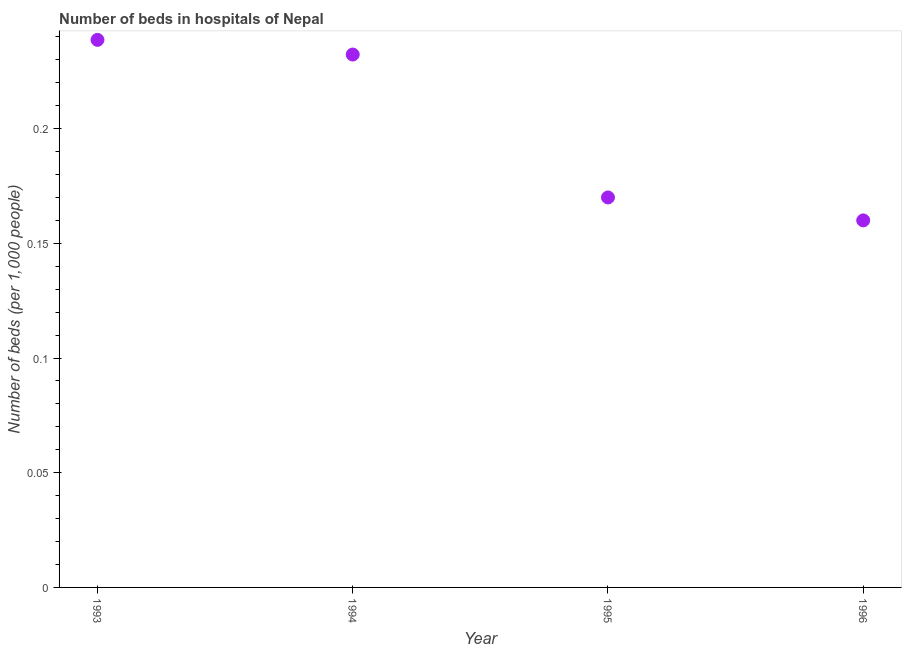What is the number of hospital beds in 1996?
Give a very brief answer. 0.16. Across all years, what is the maximum number of hospital beds?
Offer a terse response. 0.24. Across all years, what is the minimum number of hospital beds?
Your answer should be very brief. 0.16. In which year was the number of hospital beds maximum?
Provide a succinct answer. 1993. What is the sum of the number of hospital beds?
Your answer should be very brief. 0.8. What is the difference between the number of hospital beds in 1993 and 1996?
Make the answer very short. 0.08. What is the average number of hospital beds per year?
Your response must be concise. 0.2. What is the median number of hospital beds?
Keep it short and to the point. 0.2. What is the ratio of the number of hospital beds in 1993 to that in 1996?
Give a very brief answer. 1.49. What is the difference between the highest and the second highest number of hospital beds?
Keep it short and to the point. 0.01. What is the difference between the highest and the lowest number of hospital beds?
Offer a terse response. 0.08. In how many years, is the number of hospital beds greater than the average number of hospital beds taken over all years?
Your response must be concise. 2. How many dotlines are there?
Make the answer very short. 1. How many years are there in the graph?
Make the answer very short. 4. What is the title of the graph?
Offer a very short reply. Number of beds in hospitals of Nepal. What is the label or title of the Y-axis?
Offer a terse response. Number of beds (per 1,0 people). What is the Number of beds (per 1,000 people) in 1993?
Provide a succinct answer. 0.24. What is the Number of beds (per 1,000 people) in 1994?
Offer a very short reply. 0.23. What is the Number of beds (per 1,000 people) in 1995?
Your response must be concise. 0.17. What is the Number of beds (per 1,000 people) in 1996?
Your response must be concise. 0.16. What is the difference between the Number of beds (per 1,000 people) in 1993 and 1994?
Provide a short and direct response. 0.01. What is the difference between the Number of beds (per 1,000 people) in 1993 and 1995?
Give a very brief answer. 0.07. What is the difference between the Number of beds (per 1,000 people) in 1993 and 1996?
Your answer should be compact. 0.08. What is the difference between the Number of beds (per 1,000 people) in 1994 and 1995?
Keep it short and to the point. 0.06. What is the difference between the Number of beds (per 1,000 people) in 1994 and 1996?
Your answer should be very brief. 0.07. What is the ratio of the Number of beds (per 1,000 people) in 1993 to that in 1994?
Provide a short and direct response. 1.03. What is the ratio of the Number of beds (per 1,000 people) in 1993 to that in 1995?
Keep it short and to the point. 1.4. What is the ratio of the Number of beds (per 1,000 people) in 1993 to that in 1996?
Ensure brevity in your answer.  1.49. What is the ratio of the Number of beds (per 1,000 people) in 1994 to that in 1995?
Offer a terse response. 1.37. What is the ratio of the Number of beds (per 1,000 people) in 1994 to that in 1996?
Provide a succinct answer. 1.45. What is the ratio of the Number of beds (per 1,000 people) in 1995 to that in 1996?
Provide a short and direct response. 1.06. 